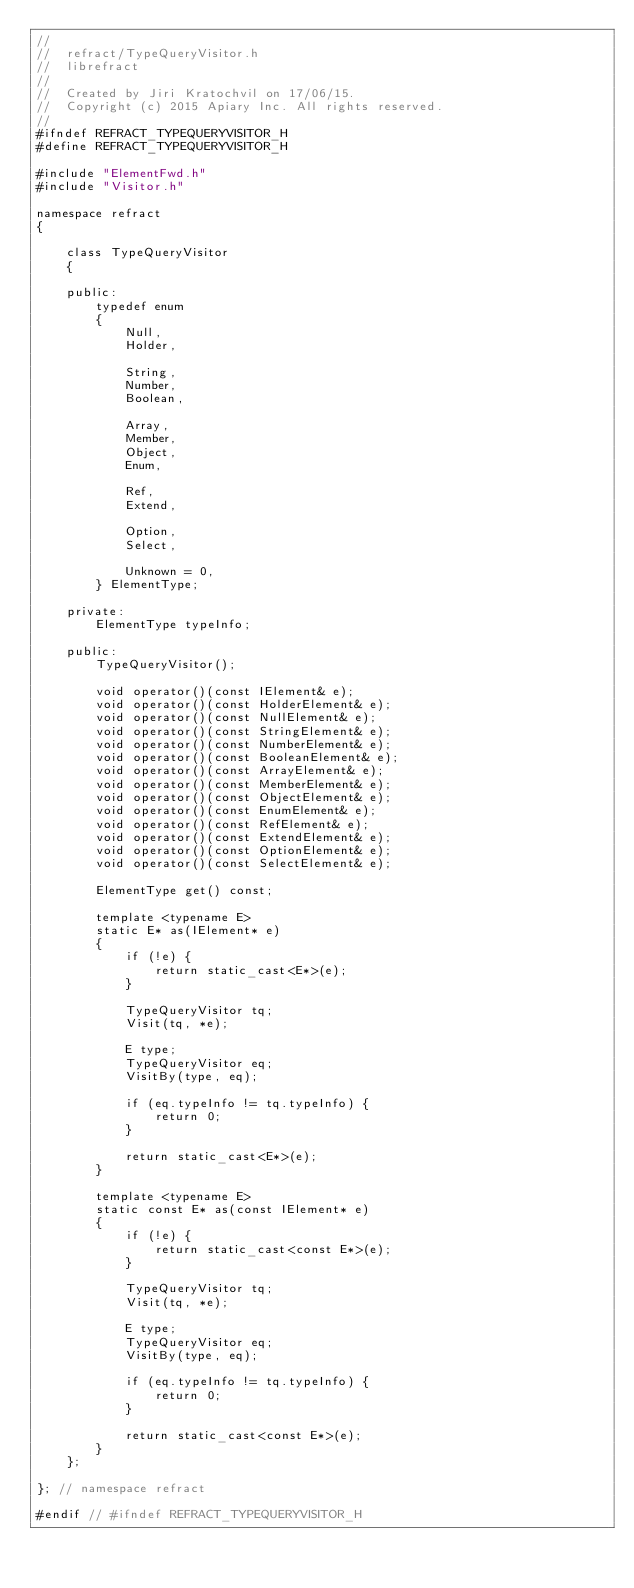<code> <loc_0><loc_0><loc_500><loc_500><_C_>//
//  refract/TypeQueryVisitor.h
//  librefract
//
//  Created by Jiri Kratochvil on 17/06/15.
//  Copyright (c) 2015 Apiary Inc. All rights reserved.
//
#ifndef REFRACT_TYPEQUERYVISITOR_H
#define REFRACT_TYPEQUERYVISITOR_H

#include "ElementFwd.h"
#include "Visitor.h"

namespace refract
{

    class TypeQueryVisitor
    {

    public:
        typedef enum
        {
            Null,
            Holder,

            String,
            Number,
            Boolean,

            Array,
            Member,
            Object,
            Enum,

            Ref,
            Extend,

            Option,
            Select,

            Unknown = 0,
        } ElementType;

    private:
        ElementType typeInfo;

    public:
        TypeQueryVisitor();

        void operator()(const IElement& e);
        void operator()(const HolderElement& e);
        void operator()(const NullElement& e);
        void operator()(const StringElement& e);
        void operator()(const NumberElement& e);
        void operator()(const BooleanElement& e);
        void operator()(const ArrayElement& e);
        void operator()(const MemberElement& e);
        void operator()(const ObjectElement& e);
        void operator()(const EnumElement& e);
        void operator()(const RefElement& e);
        void operator()(const ExtendElement& e);
        void operator()(const OptionElement& e);
        void operator()(const SelectElement& e);

        ElementType get() const;

        template <typename E>
        static E* as(IElement* e)
        {
            if (!e) {
                return static_cast<E*>(e);
            }

            TypeQueryVisitor tq;
            Visit(tq, *e);

            E type;
            TypeQueryVisitor eq;
            VisitBy(type, eq);

            if (eq.typeInfo != tq.typeInfo) {
                return 0;
            }

            return static_cast<E*>(e);
        }

        template <typename E>
        static const E* as(const IElement* e)
        {
            if (!e) {
                return static_cast<const E*>(e);
            }

            TypeQueryVisitor tq;
            Visit(tq, *e);

            E type;
            TypeQueryVisitor eq;
            VisitBy(type, eq);

            if (eq.typeInfo != tq.typeInfo) {
                return 0;
            }

            return static_cast<const E*>(e);
        }
    };

}; // namespace refract

#endif // #ifndef REFRACT_TYPEQUERYVISITOR_H
</code> 